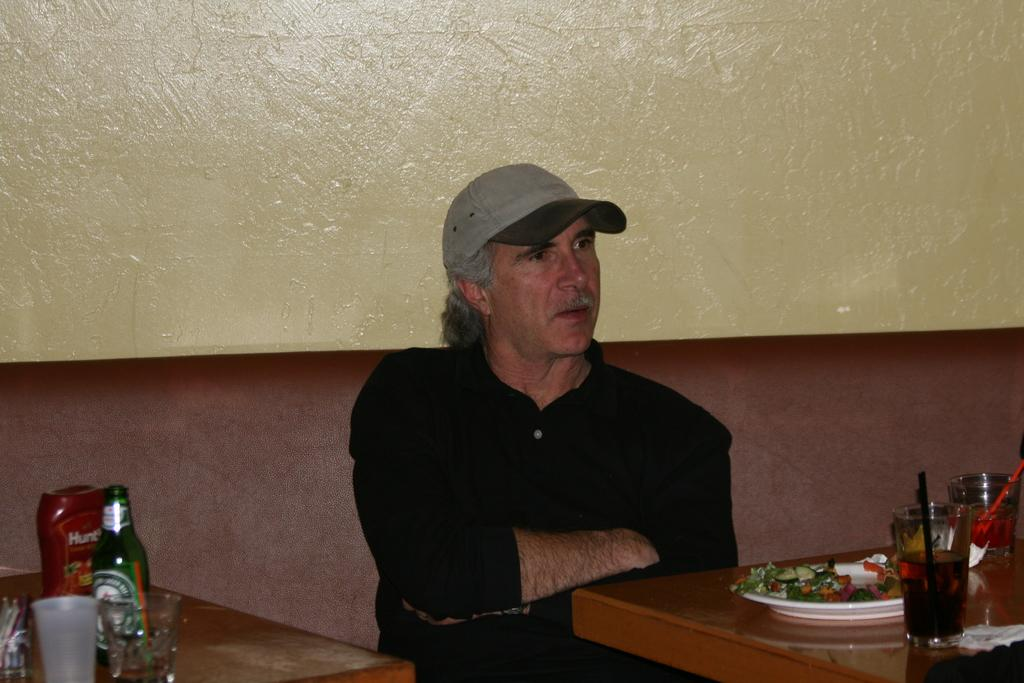Provide a one-sentence caption for the provided image. A man sits at a booth in a restaurant. 